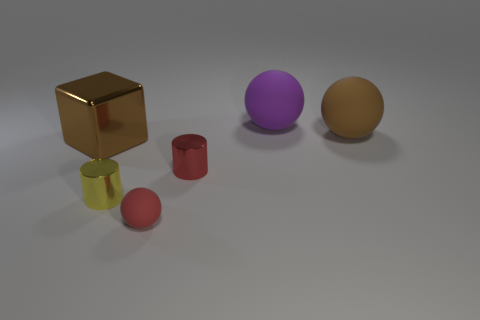Subtract all large purple spheres. How many spheres are left? 2 Subtract all red cylinders. How many cylinders are left? 1 Add 1 small shiny things. How many objects exist? 7 Subtract 2 balls. How many balls are left? 1 Add 5 matte things. How many matte things exist? 8 Subtract 0 green cylinders. How many objects are left? 6 Subtract all blocks. How many objects are left? 5 Subtract all yellow cylinders. Subtract all yellow cubes. How many cylinders are left? 1 Subtract all green cylinders. How many brown spheres are left? 1 Subtract all small red spheres. Subtract all cubes. How many objects are left? 4 